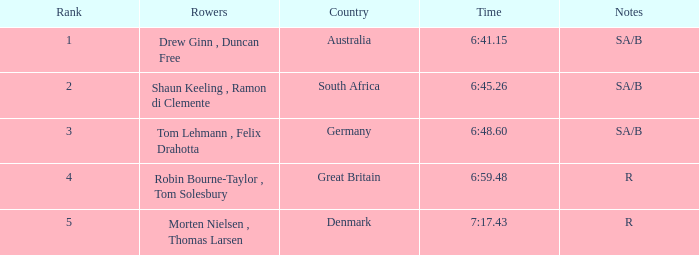What was the highest rank for rowers who represented Denmark? 5.0. Parse the table in full. {'header': ['Rank', 'Rowers', 'Country', 'Time', 'Notes'], 'rows': [['1', 'Drew Ginn , Duncan Free', 'Australia', '6:41.15', 'SA/B'], ['2', 'Shaun Keeling , Ramon di Clemente', 'South Africa', '6:45.26', 'SA/B'], ['3', 'Tom Lehmann , Felix Drahotta', 'Germany', '6:48.60', 'SA/B'], ['4', 'Robin Bourne-Taylor , Tom Solesbury', 'Great Britain', '6:59.48', 'R'], ['5', 'Morten Nielsen , Thomas Larsen', 'Denmark', '7:17.43', 'R']]} 